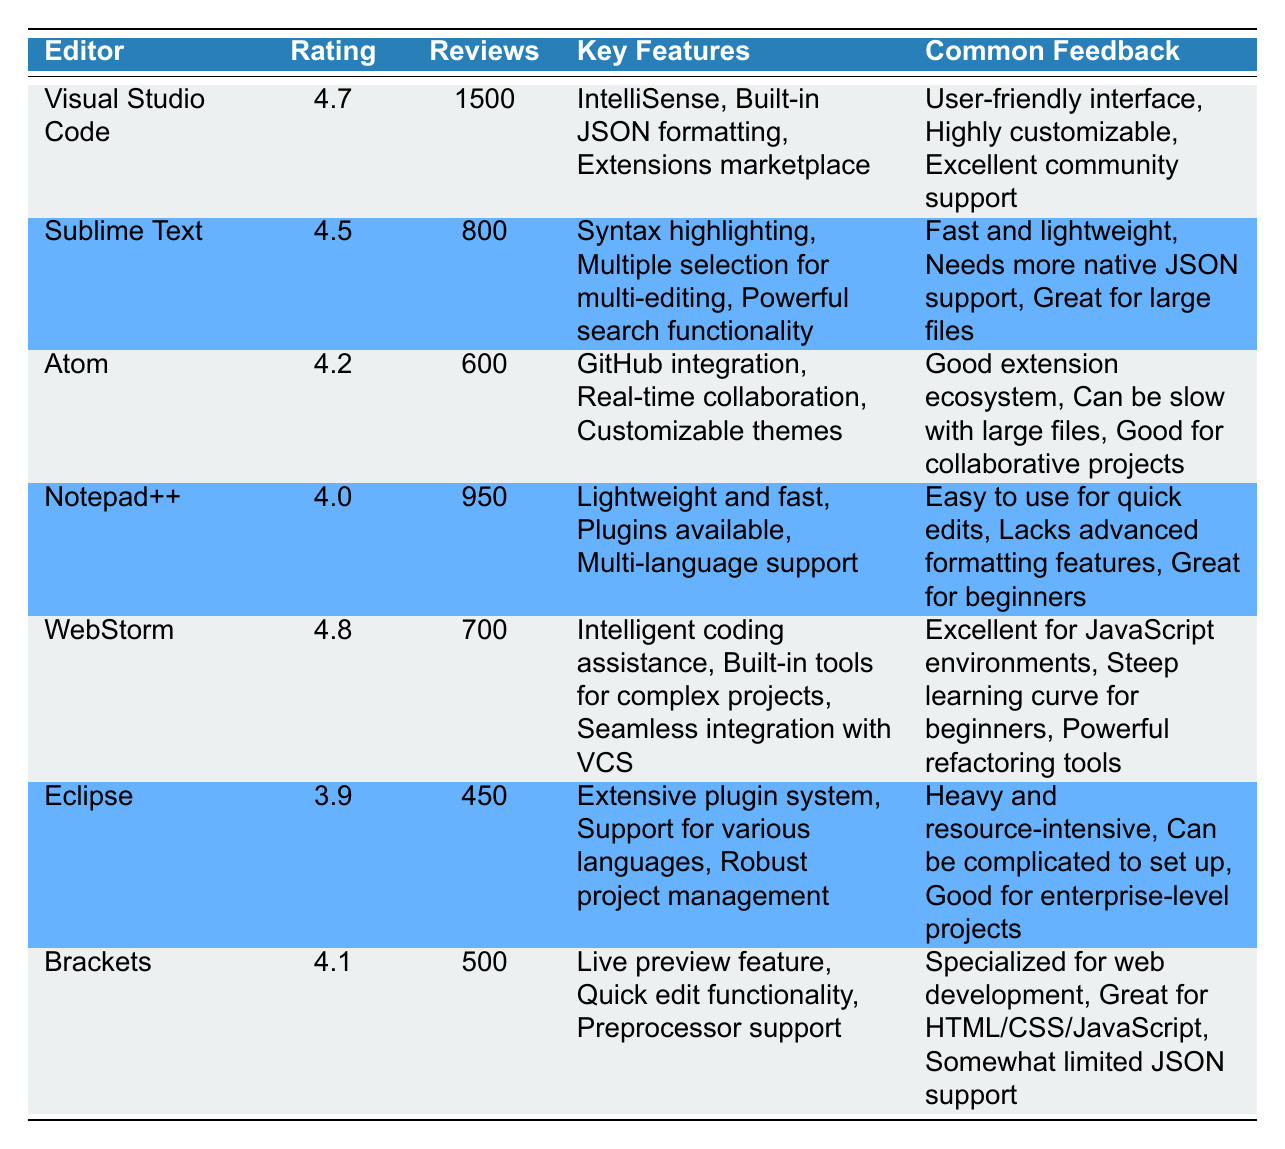What is the highest user satisfaction rating among the listed editors? The highest rating in the table is 4.8, which corresponds to WebStorm.
Answer: 4.8 Which editor has the lowest number of reviews? The editor with the lowest number of reviews is Eclipse, with only 450 reviews.
Answer: Eclipse How many reviews do Visual Studio Code and Sublime Text combined have? Visual Studio Code has 1500 reviews and Sublime Text has 800 reviews. Therefore, combined they have 1500 + 800 = 2300 reviews.
Answer: 2300 Does Atom have more reviews than Notepad++? Atom has 600 reviews while Notepad++ has 950 reviews. Since 600 is less than 950, the answer is no.
Answer: No What is the average rating of the editors listed in the table? The ratings of the editors are 4.7, 4.5, 4.2, 4.0, 4.8, 3.9, and 4.1. To find the average, sum the ratings (4.7 + 4.5 + 4.2 + 4.0 + 4.8 + 3.9 + 4.1 = 30.2) and then divide by the number of editors (30.2 / 7 = approximately 4.314).
Answer: Approximately 4.31 What feature is common to both Visual Studio Code and WebStorm? Both editors emphasize intelligent coding assistance as a key feature. Visual Studio Code highlights IntelliSense while WebStorm provides intelligent coding assistance.
Answer: Intelligent coding assistance Which editor has the most extensive plugin system? Eclipse is noted for its extensive plugin system, which is a feature mentioned in the table.
Answer: Eclipse How many tools have a rating of 4.0 or higher? Counting the ratings above 4.0, we have Visual Studio Code (4.7), Sublime Text (4.5), Atom (4.2), Notepad++ (4.0), WebStorm (4.8), and Brackets (4.1), which gives us a total of six tools.
Answer: 6 Is there any editor that has a rating of exactly 4.0? Yes, Notepad++ has a rating of exactly 4.0 according to the table.
Answer: Yes 